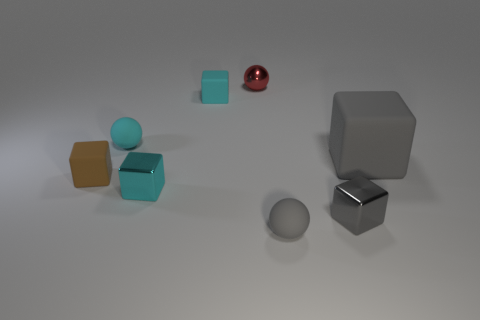Do the gray sphere and the cyan sphere have the same size?
Offer a terse response. Yes. Are the red ball that is left of the big thing and the tiny cyan ball made of the same material?
Keep it short and to the point. No. Is there any other thing that is the same material as the brown block?
Offer a terse response. Yes. There is a small gray thing behind the small ball that is to the right of the tiny shiny sphere; what number of red shiny things are in front of it?
Provide a succinct answer. 0. There is a small cyan matte thing right of the cyan sphere; is its shape the same as the large object?
Give a very brief answer. Yes. How many objects are either big green spheres or small blocks on the right side of the tiny cyan sphere?
Ensure brevity in your answer.  3. Is the number of tiny brown cubes behind the brown block greater than the number of small cyan cylinders?
Provide a succinct answer. No. Are there an equal number of large gray matte things on the right side of the tiny cyan matte sphere and gray matte balls that are on the left side of the cyan rubber block?
Give a very brief answer. No. Is there a tiny brown object behind the thing on the right side of the tiny gray block?
Offer a very short reply. No. The large matte object has what shape?
Your answer should be very brief. Cube. 